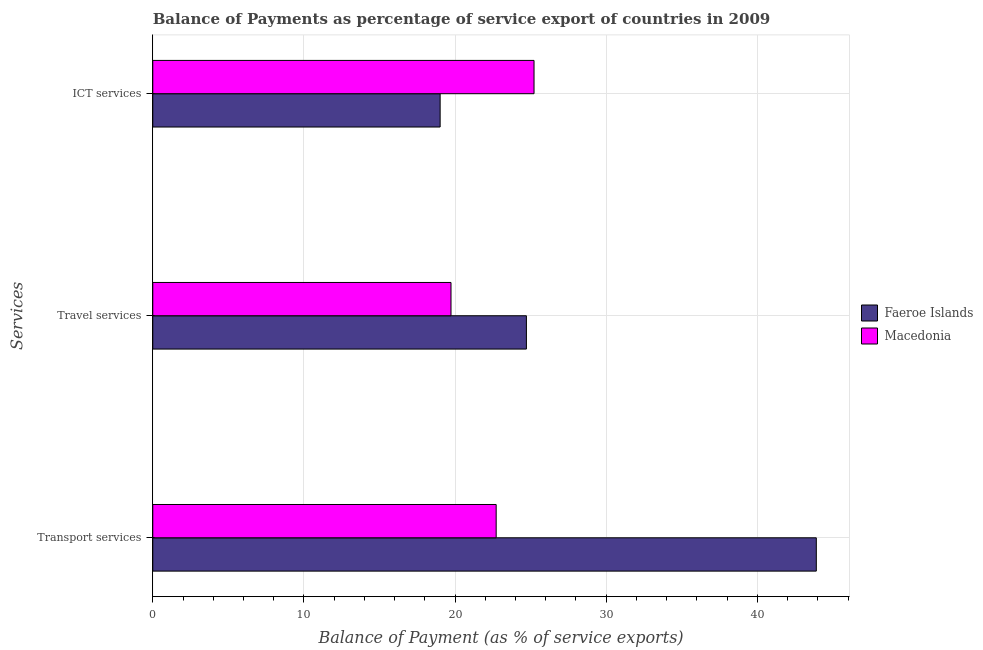How many different coloured bars are there?
Your response must be concise. 2. How many bars are there on the 1st tick from the top?
Your answer should be compact. 2. What is the label of the 2nd group of bars from the top?
Offer a very short reply. Travel services. What is the balance of payment of ict services in Faeroe Islands?
Make the answer very short. 19.01. Across all countries, what is the maximum balance of payment of travel services?
Offer a terse response. 24.72. Across all countries, what is the minimum balance of payment of travel services?
Provide a succinct answer. 19.73. In which country was the balance of payment of ict services maximum?
Provide a short and direct response. Macedonia. In which country was the balance of payment of transport services minimum?
Keep it short and to the point. Macedonia. What is the total balance of payment of ict services in the graph?
Provide a succinct answer. 44.24. What is the difference between the balance of payment of travel services in Faeroe Islands and that in Macedonia?
Offer a very short reply. 4.99. What is the difference between the balance of payment of travel services in Faeroe Islands and the balance of payment of transport services in Macedonia?
Offer a very short reply. 2. What is the average balance of payment of transport services per country?
Provide a short and direct response. 33.31. What is the difference between the balance of payment of travel services and balance of payment of ict services in Faeroe Islands?
Your answer should be compact. 5.71. What is the ratio of the balance of payment of travel services in Macedonia to that in Faeroe Islands?
Provide a short and direct response. 0.8. What is the difference between the highest and the second highest balance of payment of travel services?
Ensure brevity in your answer.  4.99. What is the difference between the highest and the lowest balance of payment of travel services?
Ensure brevity in your answer.  4.99. In how many countries, is the balance of payment of ict services greater than the average balance of payment of ict services taken over all countries?
Offer a very short reply. 1. Is the sum of the balance of payment of transport services in Faeroe Islands and Macedonia greater than the maximum balance of payment of ict services across all countries?
Keep it short and to the point. Yes. What does the 1st bar from the top in ICT services represents?
Provide a succinct answer. Macedonia. What does the 2nd bar from the bottom in Travel services represents?
Your response must be concise. Macedonia. Are all the bars in the graph horizontal?
Give a very brief answer. Yes. How many countries are there in the graph?
Give a very brief answer. 2. Does the graph contain any zero values?
Offer a very short reply. No. What is the title of the graph?
Keep it short and to the point. Balance of Payments as percentage of service export of countries in 2009. What is the label or title of the X-axis?
Keep it short and to the point. Balance of Payment (as % of service exports). What is the label or title of the Y-axis?
Offer a terse response. Services. What is the Balance of Payment (as % of service exports) of Faeroe Islands in Transport services?
Make the answer very short. 43.9. What is the Balance of Payment (as % of service exports) of Macedonia in Transport services?
Keep it short and to the point. 22.72. What is the Balance of Payment (as % of service exports) of Faeroe Islands in Travel services?
Give a very brief answer. 24.72. What is the Balance of Payment (as % of service exports) in Macedonia in Travel services?
Your response must be concise. 19.73. What is the Balance of Payment (as % of service exports) in Faeroe Islands in ICT services?
Provide a succinct answer. 19.01. What is the Balance of Payment (as % of service exports) of Macedonia in ICT services?
Provide a short and direct response. 25.22. Across all Services, what is the maximum Balance of Payment (as % of service exports) in Faeroe Islands?
Your response must be concise. 43.9. Across all Services, what is the maximum Balance of Payment (as % of service exports) in Macedonia?
Your response must be concise. 25.22. Across all Services, what is the minimum Balance of Payment (as % of service exports) of Faeroe Islands?
Provide a succinct answer. 19.01. Across all Services, what is the minimum Balance of Payment (as % of service exports) of Macedonia?
Your response must be concise. 19.73. What is the total Balance of Payment (as % of service exports) in Faeroe Islands in the graph?
Ensure brevity in your answer.  87.63. What is the total Balance of Payment (as % of service exports) in Macedonia in the graph?
Your answer should be compact. 67.68. What is the difference between the Balance of Payment (as % of service exports) in Faeroe Islands in Transport services and that in Travel services?
Make the answer very short. 19.18. What is the difference between the Balance of Payment (as % of service exports) in Macedonia in Transport services and that in Travel services?
Your answer should be very brief. 2.99. What is the difference between the Balance of Payment (as % of service exports) of Faeroe Islands in Transport services and that in ICT services?
Your answer should be compact. 24.89. What is the difference between the Balance of Payment (as % of service exports) of Macedonia in Transport services and that in ICT services?
Provide a succinct answer. -2.5. What is the difference between the Balance of Payment (as % of service exports) in Faeroe Islands in Travel services and that in ICT services?
Offer a very short reply. 5.71. What is the difference between the Balance of Payment (as % of service exports) of Macedonia in Travel services and that in ICT services?
Make the answer very short. -5.49. What is the difference between the Balance of Payment (as % of service exports) of Faeroe Islands in Transport services and the Balance of Payment (as % of service exports) of Macedonia in Travel services?
Give a very brief answer. 24.17. What is the difference between the Balance of Payment (as % of service exports) in Faeroe Islands in Transport services and the Balance of Payment (as % of service exports) in Macedonia in ICT services?
Make the answer very short. 18.68. What is the difference between the Balance of Payment (as % of service exports) in Faeroe Islands in Travel services and the Balance of Payment (as % of service exports) in Macedonia in ICT services?
Make the answer very short. -0.5. What is the average Balance of Payment (as % of service exports) of Faeroe Islands per Services?
Provide a succinct answer. 29.21. What is the average Balance of Payment (as % of service exports) in Macedonia per Services?
Your answer should be very brief. 22.56. What is the difference between the Balance of Payment (as % of service exports) in Faeroe Islands and Balance of Payment (as % of service exports) in Macedonia in Transport services?
Provide a short and direct response. 21.18. What is the difference between the Balance of Payment (as % of service exports) in Faeroe Islands and Balance of Payment (as % of service exports) in Macedonia in Travel services?
Your response must be concise. 4.99. What is the difference between the Balance of Payment (as % of service exports) of Faeroe Islands and Balance of Payment (as % of service exports) of Macedonia in ICT services?
Keep it short and to the point. -6.21. What is the ratio of the Balance of Payment (as % of service exports) in Faeroe Islands in Transport services to that in Travel services?
Keep it short and to the point. 1.78. What is the ratio of the Balance of Payment (as % of service exports) in Macedonia in Transport services to that in Travel services?
Your answer should be compact. 1.15. What is the ratio of the Balance of Payment (as % of service exports) in Faeroe Islands in Transport services to that in ICT services?
Ensure brevity in your answer.  2.31. What is the ratio of the Balance of Payment (as % of service exports) in Macedonia in Transport services to that in ICT services?
Give a very brief answer. 0.9. What is the ratio of the Balance of Payment (as % of service exports) in Faeroe Islands in Travel services to that in ICT services?
Your answer should be very brief. 1.3. What is the ratio of the Balance of Payment (as % of service exports) of Macedonia in Travel services to that in ICT services?
Provide a succinct answer. 0.78. What is the difference between the highest and the second highest Balance of Payment (as % of service exports) in Faeroe Islands?
Make the answer very short. 19.18. What is the difference between the highest and the second highest Balance of Payment (as % of service exports) of Macedonia?
Offer a very short reply. 2.5. What is the difference between the highest and the lowest Balance of Payment (as % of service exports) of Faeroe Islands?
Your response must be concise. 24.89. What is the difference between the highest and the lowest Balance of Payment (as % of service exports) in Macedonia?
Provide a short and direct response. 5.49. 